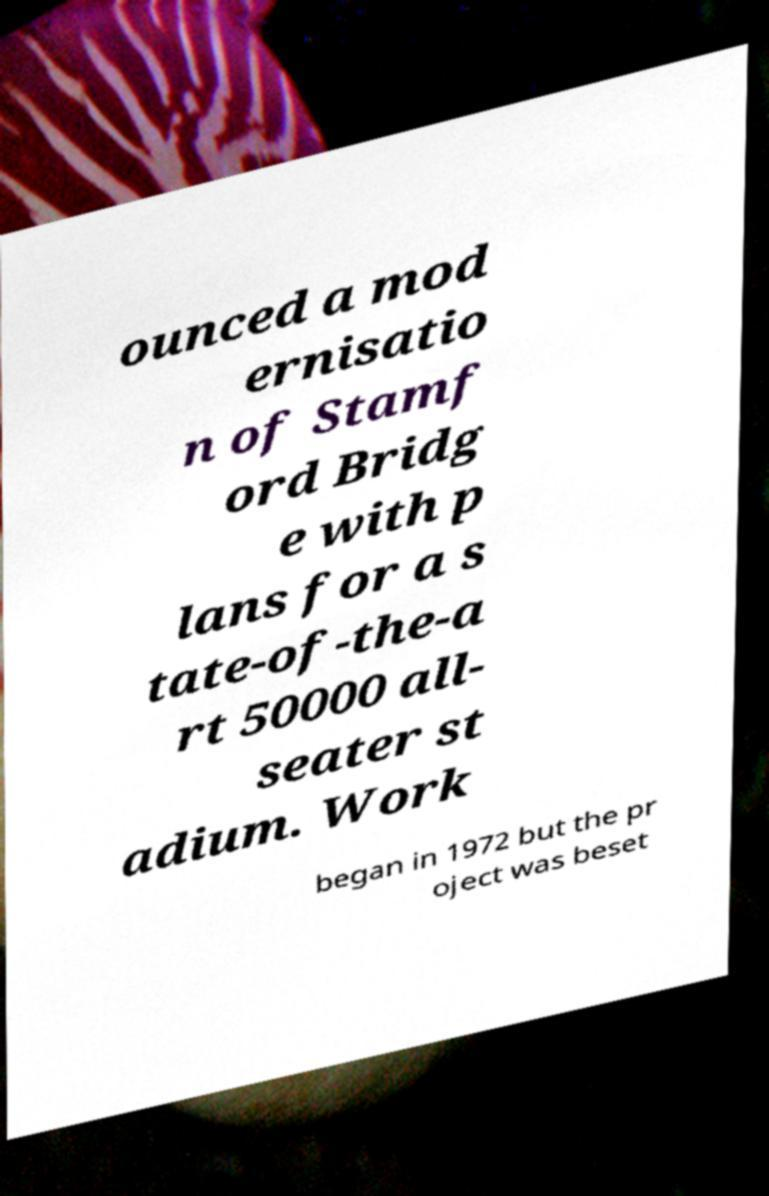Can you read and provide the text displayed in the image?This photo seems to have some interesting text. Can you extract and type it out for me? ounced a mod ernisatio n of Stamf ord Bridg e with p lans for a s tate-of-the-a rt 50000 all- seater st adium. Work began in 1972 but the pr oject was beset 